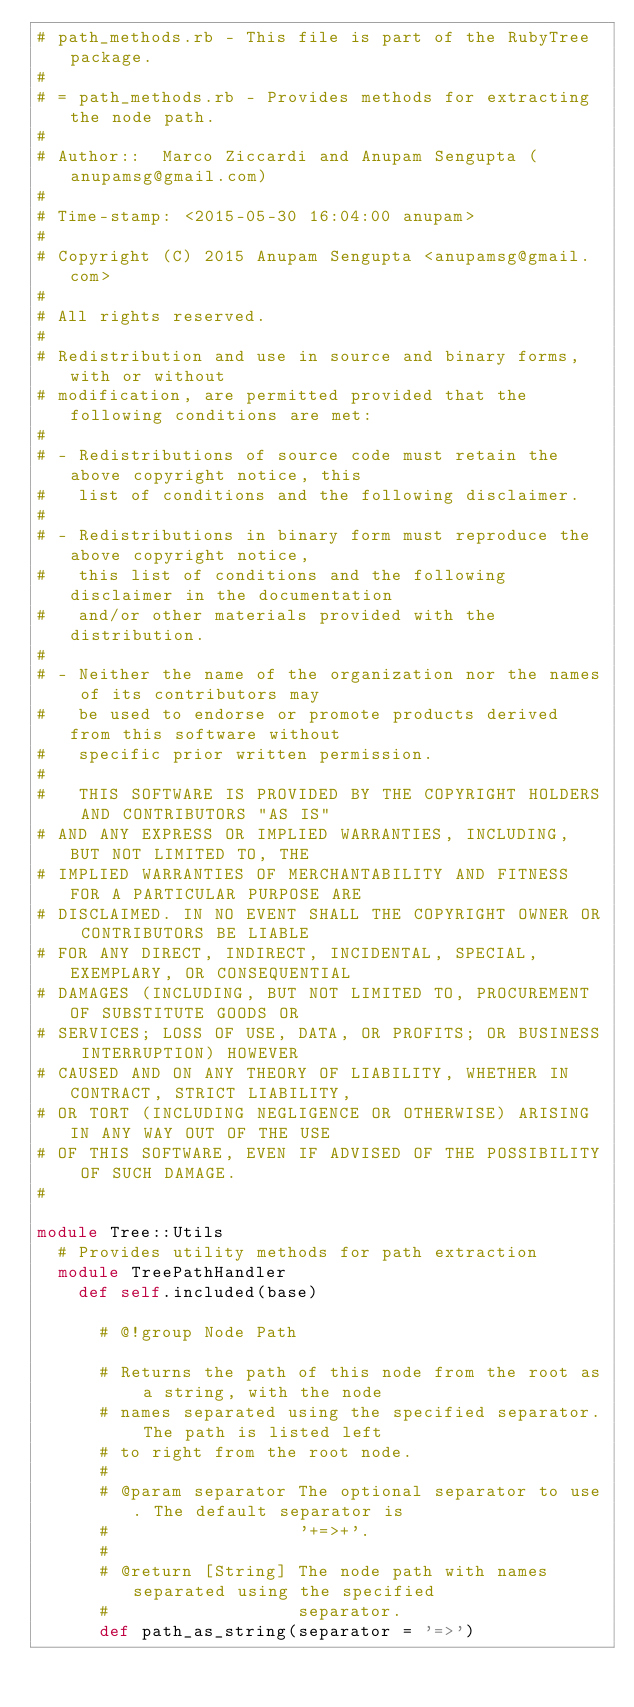<code> <loc_0><loc_0><loc_500><loc_500><_Ruby_># path_methods.rb - This file is part of the RubyTree package.
#
# = path_methods.rb - Provides methods for extracting the node path.
#
# Author::  Marco Ziccardi and Anupam Sengupta (anupamsg@gmail.com)
#
# Time-stamp: <2015-05-30 16:04:00 anupam>
#
# Copyright (C) 2015 Anupam Sengupta <anupamsg@gmail.com>
#
# All rights reserved.
#
# Redistribution and use in source and binary forms, with or without
# modification, are permitted provided that the following conditions are met:
#
# - Redistributions of source code must retain the above copyright notice, this
#   list of conditions and the following disclaimer.
#
# - Redistributions in binary form must reproduce the above copyright notice,
#   this list of conditions and the following disclaimer in the documentation
#   and/or other materials provided with the distribution.
#
# - Neither the name of the organization nor the names of its contributors may
#   be used to endorse or promote products derived from this software without
#   specific prior written permission.
#
#   THIS SOFTWARE IS PROVIDED BY THE COPYRIGHT HOLDERS AND CONTRIBUTORS "AS IS"
# AND ANY EXPRESS OR IMPLIED WARRANTIES, INCLUDING, BUT NOT LIMITED TO, THE
# IMPLIED WARRANTIES OF MERCHANTABILITY AND FITNESS FOR A PARTICULAR PURPOSE ARE
# DISCLAIMED. IN NO EVENT SHALL THE COPYRIGHT OWNER OR CONTRIBUTORS BE LIABLE
# FOR ANY DIRECT, INDIRECT, INCIDENTAL, SPECIAL, EXEMPLARY, OR CONSEQUENTIAL
# DAMAGES (INCLUDING, BUT NOT LIMITED TO, PROCUREMENT OF SUBSTITUTE GOODS OR
# SERVICES; LOSS OF USE, DATA, OR PROFITS; OR BUSINESS INTERRUPTION) HOWEVER
# CAUSED AND ON ANY THEORY OF LIABILITY, WHETHER IN CONTRACT, STRICT LIABILITY,
# OR TORT (INCLUDING NEGLIGENCE OR OTHERWISE) ARISING IN ANY WAY OUT OF THE USE
# OF THIS SOFTWARE, EVEN IF ADVISED OF THE POSSIBILITY OF SUCH DAMAGE.
#

module Tree::Utils
  # Provides utility methods for path extraction
  module TreePathHandler
    def self.included(base)

      # @!group Node Path

      # Returns the path of this node from the root as a string, with the node
      # names separated using the specified separator. The path is listed left
      # to right from the root node.
      #
      # @param separator The optional separator to use. The default separator is
      #                  '+=>+'.
      #
      # @return [String] The node path with names separated using the specified
      #                  separator.
      def path_as_string(separator = '=>')</code> 